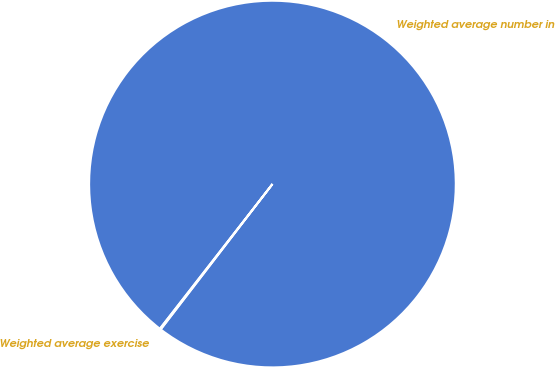Convert chart. <chart><loc_0><loc_0><loc_500><loc_500><pie_chart><fcel>Weighted average number in<fcel>Weighted average exercise<nl><fcel>99.9%<fcel>0.1%<nl></chart> 